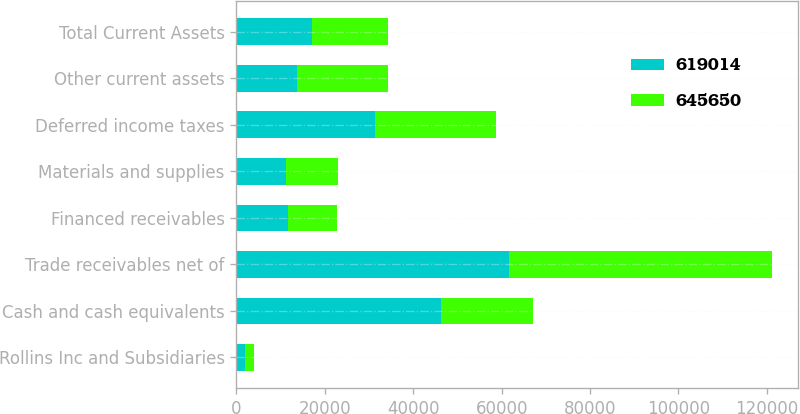<chart> <loc_0><loc_0><loc_500><loc_500><stacked_bar_chart><ecel><fcel>Rollins Inc and Subsidiaries<fcel>Cash and cash equivalents<fcel>Trade receivables net of<fcel>Financed receivables<fcel>Materials and supplies<fcel>Deferred income taxes<fcel>Other current assets<fcel>Total Current Assets<nl><fcel>619014<fcel>2011<fcel>46275<fcel>61687<fcel>11659<fcel>11125<fcel>31272<fcel>13804<fcel>17092<nl><fcel>645650<fcel>2010<fcel>20913<fcel>59389<fcel>11044<fcel>11899<fcel>27396<fcel>20380<fcel>17092<nl></chart> 